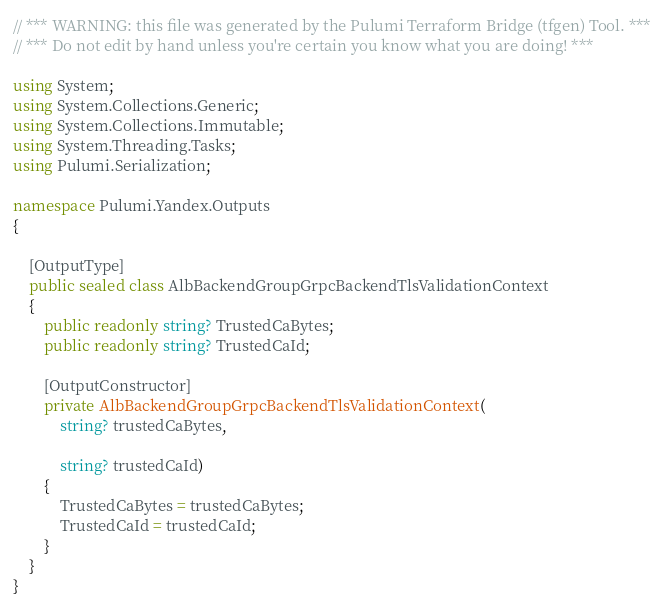<code> <loc_0><loc_0><loc_500><loc_500><_C#_>// *** WARNING: this file was generated by the Pulumi Terraform Bridge (tfgen) Tool. ***
// *** Do not edit by hand unless you're certain you know what you are doing! ***

using System;
using System.Collections.Generic;
using System.Collections.Immutable;
using System.Threading.Tasks;
using Pulumi.Serialization;

namespace Pulumi.Yandex.Outputs
{

    [OutputType]
    public sealed class AlbBackendGroupGrpcBackendTlsValidationContext
    {
        public readonly string? TrustedCaBytes;
        public readonly string? TrustedCaId;

        [OutputConstructor]
        private AlbBackendGroupGrpcBackendTlsValidationContext(
            string? trustedCaBytes,

            string? trustedCaId)
        {
            TrustedCaBytes = trustedCaBytes;
            TrustedCaId = trustedCaId;
        }
    }
}
</code> 